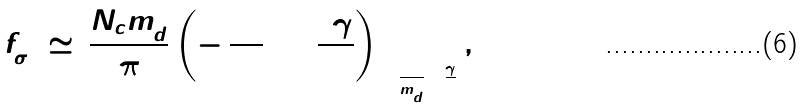Convert formula to latex. <formula><loc_0><loc_0><loc_500><loc_500>f _ { \sigma } ^ { 2 } \, \simeq \, \frac { N _ { c } m _ { d } ^ { 2 } } { 8 \pi ^ { 2 } } \left ( - \, \frac { 1 7 } { 1 2 } \, + \, \frac { 3 \gamma } { 2 0 } \right ) _ { \ln \frac { \Lambda ^ { 2 } } { m _ { d } ^ { 2 } } = \frac { \gamma } { 2 } } ,</formula> 